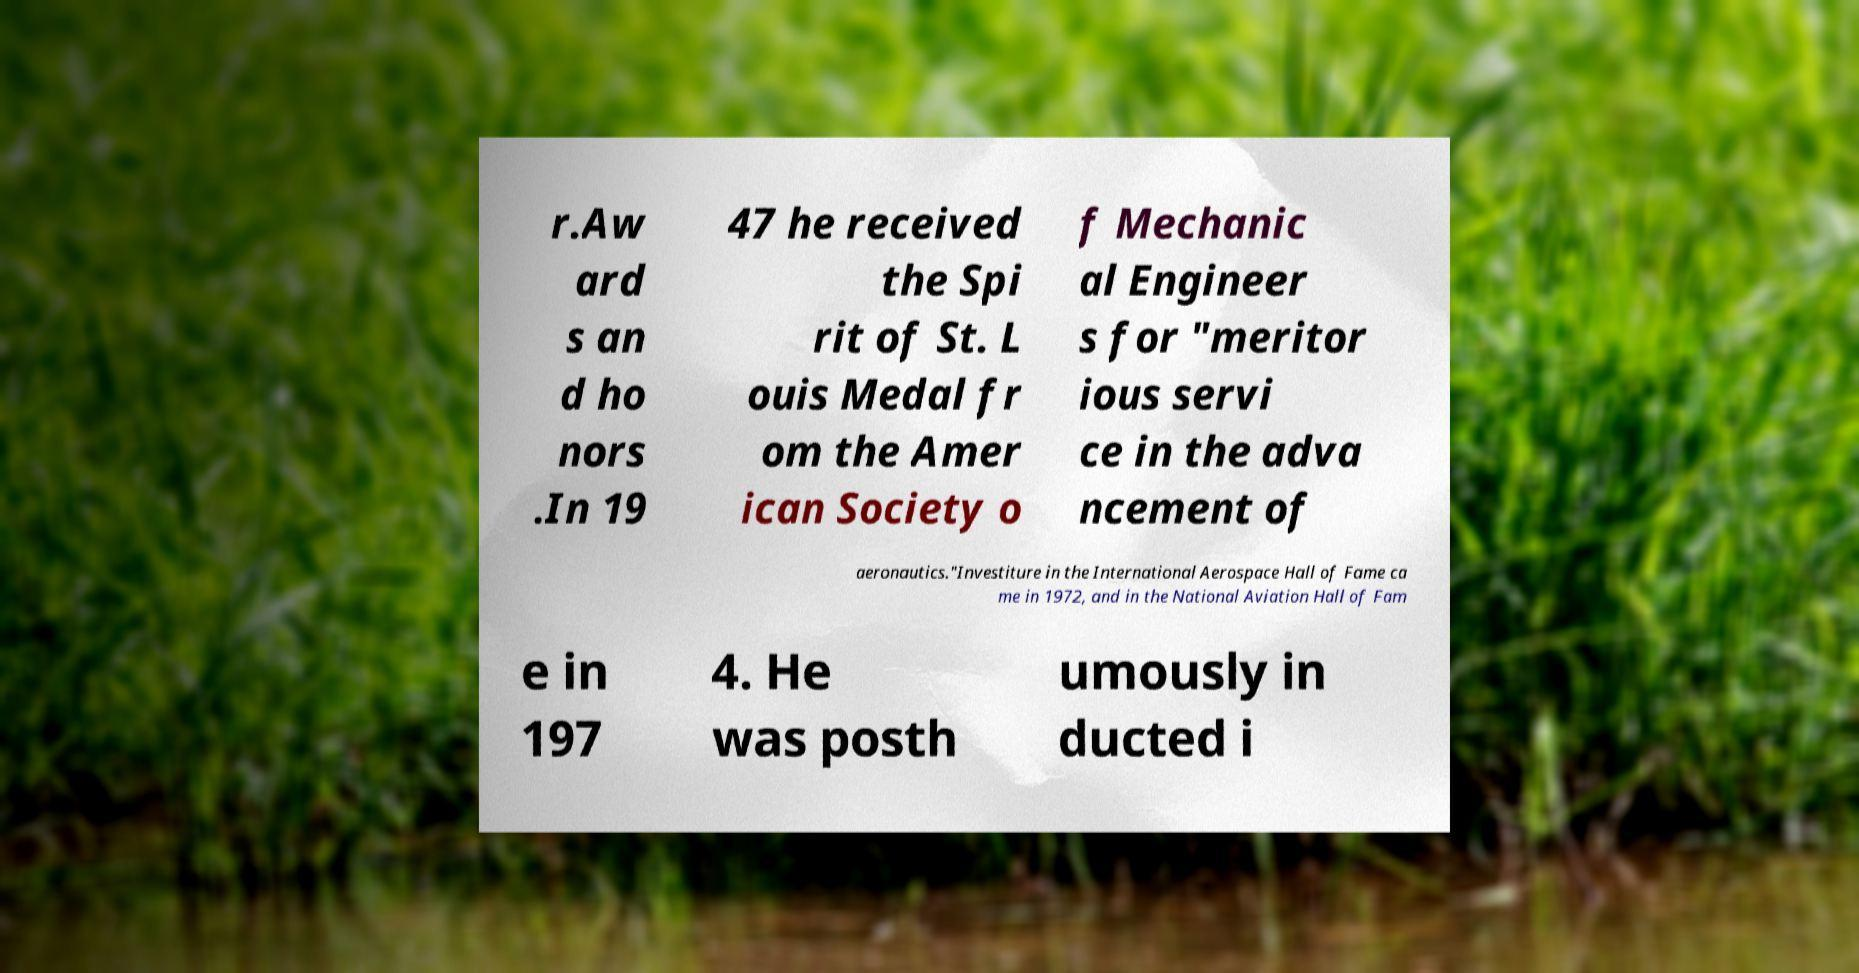Can you read and provide the text displayed in the image?This photo seems to have some interesting text. Can you extract and type it out for me? r.Aw ard s an d ho nors .In 19 47 he received the Spi rit of St. L ouis Medal fr om the Amer ican Society o f Mechanic al Engineer s for "meritor ious servi ce in the adva ncement of aeronautics."Investiture in the International Aerospace Hall of Fame ca me in 1972, and in the National Aviation Hall of Fam e in 197 4. He was posth umously in ducted i 